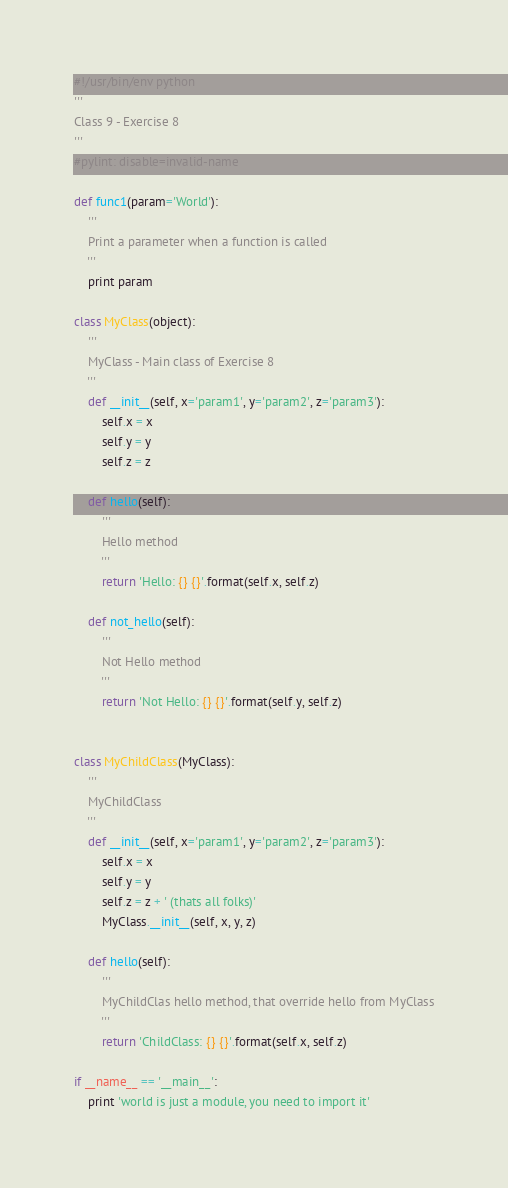Convert code to text. <code><loc_0><loc_0><loc_500><loc_500><_Python_>#!/usr/bin/env python
'''
Class 9 - Exercise 8
'''
#pylint: disable=invalid-name

def func1(param='World'):
    '''
    Print a parameter when a function is called
    '''
    print param

class MyClass(object):
    '''
    MyClass - Main class of Exercise 8
    '''
    def __init__(self, x='param1', y='param2', z='param3'):
        self.x = x
        self.y = y
        self.z = z

    def hello(self):
        '''
        Hello method
        '''
        return 'Hello: {} {}'.format(self.x, self.z)

    def not_hello(self):
        '''
        Not Hello method
        '''
        return 'Not Hello: {} {}'.format(self.y, self.z)


class MyChildClass(MyClass):
    '''
    MyChildClass
    '''
    def __init__(self, x='param1', y='param2', z='param3'):
        self.x = x
        self.y = y
        self.z = z + ' (thats all folks)'
        MyClass.__init__(self, x, y, z)

    def hello(self):
        '''
        MyChildClas hello method, that override hello from MyClass
        '''
        return 'ChildClass: {} {}'.format(self.x, self.z)

if __name__ == '__main__':
    print 'world is just a module, you need to import it'
</code> 